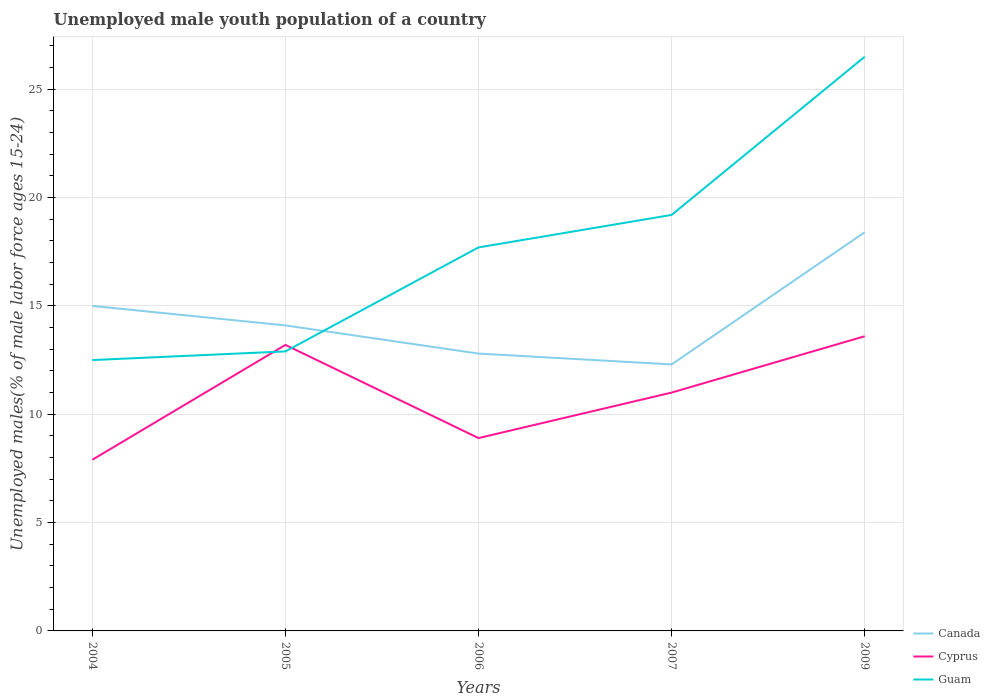How many different coloured lines are there?
Provide a short and direct response. 3. Is the number of lines equal to the number of legend labels?
Offer a very short reply. Yes. Across all years, what is the maximum percentage of unemployed male youth population in Canada?
Your response must be concise. 12.3. In which year was the percentage of unemployed male youth population in Guam maximum?
Your response must be concise. 2004. What is the total percentage of unemployed male youth population in Cyprus in the graph?
Offer a very short reply. 4.3. What is the difference between the highest and the second highest percentage of unemployed male youth population in Canada?
Keep it short and to the point. 6.1. What is the difference between the highest and the lowest percentage of unemployed male youth population in Canada?
Keep it short and to the point. 2. How many lines are there?
Offer a very short reply. 3. How many years are there in the graph?
Keep it short and to the point. 5. Are the values on the major ticks of Y-axis written in scientific E-notation?
Make the answer very short. No. Does the graph contain any zero values?
Provide a short and direct response. No. Does the graph contain grids?
Your answer should be very brief. Yes. How are the legend labels stacked?
Offer a terse response. Vertical. What is the title of the graph?
Provide a short and direct response. Unemployed male youth population of a country. What is the label or title of the X-axis?
Offer a terse response. Years. What is the label or title of the Y-axis?
Keep it short and to the point. Unemployed males(% of male labor force ages 15-24). What is the Unemployed males(% of male labor force ages 15-24) in Cyprus in 2004?
Offer a terse response. 7.9. What is the Unemployed males(% of male labor force ages 15-24) of Guam in 2004?
Offer a terse response. 12.5. What is the Unemployed males(% of male labor force ages 15-24) in Canada in 2005?
Offer a terse response. 14.1. What is the Unemployed males(% of male labor force ages 15-24) in Cyprus in 2005?
Your answer should be compact. 13.2. What is the Unemployed males(% of male labor force ages 15-24) in Guam in 2005?
Offer a very short reply. 12.9. What is the Unemployed males(% of male labor force ages 15-24) of Canada in 2006?
Give a very brief answer. 12.8. What is the Unemployed males(% of male labor force ages 15-24) in Cyprus in 2006?
Your answer should be very brief. 8.9. What is the Unemployed males(% of male labor force ages 15-24) in Guam in 2006?
Your response must be concise. 17.7. What is the Unemployed males(% of male labor force ages 15-24) of Canada in 2007?
Ensure brevity in your answer.  12.3. What is the Unemployed males(% of male labor force ages 15-24) in Guam in 2007?
Your response must be concise. 19.2. What is the Unemployed males(% of male labor force ages 15-24) in Canada in 2009?
Give a very brief answer. 18.4. What is the Unemployed males(% of male labor force ages 15-24) in Cyprus in 2009?
Provide a succinct answer. 13.6. Across all years, what is the maximum Unemployed males(% of male labor force ages 15-24) in Canada?
Give a very brief answer. 18.4. Across all years, what is the maximum Unemployed males(% of male labor force ages 15-24) of Cyprus?
Your answer should be compact. 13.6. Across all years, what is the maximum Unemployed males(% of male labor force ages 15-24) of Guam?
Offer a very short reply. 26.5. Across all years, what is the minimum Unemployed males(% of male labor force ages 15-24) of Canada?
Keep it short and to the point. 12.3. Across all years, what is the minimum Unemployed males(% of male labor force ages 15-24) in Cyprus?
Offer a very short reply. 7.9. Across all years, what is the minimum Unemployed males(% of male labor force ages 15-24) of Guam?
Provide a succinct answer. 12.5. What is the total Unemployed males(% of male labor force ages 15-24) in Canada in the graph?
Offer a very short reply. 72.6. What is the total Unemployed males(% of male labor force ages 15-24) of Cyprus in the graph?
Your response must be concise. 54.6. What is the total Unemployed males(% of male labor force ages 15-24) of Guam in the graph?
Keep it short and to the point. 88.8. What is the difference between the Unemployed males(% of male labor force ages 15-24) in Cyprus in 2004 and that in 2006?
Your answer should be very brief. -1. What is the difference between the Unemployed males(% of male labor force ages 15-24) in Guam in 2004 and that in 2006?
Your response must be concise. -5.2. What is the difference between the Unemployed males(% of male labor force ages 15-24) in Cyprus in 2004 and that in 2007?
Your response must be concise. -3.1. What is the difference between the Unemployed males(% of male labor force ages 15-24) in Canada in 2004 and that in 2009?
Give a very brief answer. -3.4. What is the difference between the Unemployed males(% of male labor force ages 15-24) in Guam in 2005 and that in 2006?
Give a very brief answer. -4.8. What is the difference between the Unemployed males(% of male labor force ages 15-24) in Cyprus in 2005 and that in 2007?
Give a very brief answer. 2.2. What is the difference between the Unemployed males(% of male labor force ages 15-24) of Guam in 2005 and that in 2007?
Provide a short and direct response. -6.3. What is the difference between the Unemployed males(% of male labor force ages 15-24) in Canada in 2005 and that in 2009?
Your answer should be very brief. -4.3. What is the difference between the Unemployed males(% of male labor force ages 15-24) of Guam in 2005 and that in 2009?
Your answer should be very brief. -13.6. What is the difference between the Unemployed males(% of male labor force ages 15-24) of Canada in 2006 and that in 2007?
Offer a very short reply. 0.5. What is the difference between the Unemployed males(% of male labor force ages 15-24) in Cyprus in 2006 and that in 2007?
Provide a succinct answer. -2.1. What is the difference between the Unemployed males(% of male labor force ages 15-24) of Canada in 2006 and that in 2009?
Make the answer very short. -5.6. What is the difference between the Unemployed males(% of male labor force ages 15-24) of Guam in 2006 and that in 2009?
Keep it short and to the point. -8.8. What is the difference between the Unemployed males(% of male labor force ages 15-24) in Cyprus in 2007 and that in 2009?
Your answer should be compact. -2.6. What is the difference between the Unemployed males(% of male labor force ages 15-24) in Canada in 2004 and the Unemployed males(% of male labor force ages 15-24) in Cyprus in 2005?
Provide a succinct answer. 1.8. What is the difference between the Unemployed males(% of male labor force ages 15-24) in Cyprus in 2004 and the Unemployed males(% of male labor force ages 15-24) in Guam in 2005?
Provide a short and direct response. -5. What is the difference between the Unemployed males(% of male labor force ages 15-24) of Canada in 2004 and the Unemployed males(% of male labor force ages 15-24) of Cyprus in 2006?
Your answer should be very brief. 6.1. What is the difference between the Unemployed males(% of male labor force ages 15-24) in Cyprus in 2004 and the Unemployed males(% of male labor force ages 15-24) in Guam in 2006?
Your answer should be very brief. -9.8. What is the difference between the Unemployed males(% of male labor force ages 15-24) of Canada in 2004 and the Unemployed males(% of male labor force ages 15-24) of Cyprus in 2007?
Your answer should be compact. 4. What is the difference between the Unemployed males(% of male labor force ages 15-24) in Canada in 2004 and the Unemployed males(% of male labor force ages 15-24) in Guam in 2007?
Your response must be concise. -4.2. What is the difference between the Unemployed males(% of male labor force ages 15-24) in Canada in 2004 and the Unemployed males(% of male labor force ages 15-24) in Cyprus in 2009?
Ensure brevity in your answer.  1.4. What is the difference between the Unemployed males(% of male labor force ages 15-24) of Canada in 2004 and the Unemployed males(% of male labor force ages 15-24) of Guam in 2009?
Ensure brevity in your answer.  -11.5. What is the difference between the Unemployed males(% of male labor force ages 15-24) of Cyprus in 2004 and the Unemployed males(% of male labor force ages 15-24) of Guam in 2009?
Your answer should be very brief. -18.6. What is the difference between the Unemployed males(% of male labor force ages 15-24) of Canada in 2005 and the Unemployed males(% of male labor force ages 15-24) of Guam in 2007?
Provide a succinct answer. -5.1. What is the difference between the Unemployed males(% of male labor force ages 15-24) of Cyprus in 2005 and the Unemployed males(% of male labor force ages 15-24) of Guam in 2007?
Make the answer very short. -6. What is the difference between the Unemployed males(% of male labor force ages 15-24) in Canada in 2005 and the Unemployed males(% of male labor force ages 15-24) in Cyprus in 2009?
Ensure brevity in your answer.  0.5. What is the difference between the Unemployed males(% of male labor force ages 15-24) in Canada in 2005 and the Unemployed males(% of male labor force ages 15-24) in Guam in 2009?
Keep it short and to the point. -12.4. What is the difference between the Unemployed males(% of male labor force ages 15-24) of Cyprus in 2005 and the Unemployed males(% of male labor force ages 15-24) of Guam in 2009?
Provide a short and direct response. -13.3. What is the difference between the Unemployed males(% of male labor force ages 15-24) of Canada in 2006 and the Unemployed males(% of male labor force ages 15-24) of Cyprus in 2007?
Your answer should be compact. 1.8. What is the difference between the Unemployed males(% of male labor force ages 15-24) in Canada in 2006 and the Unemployed males(% of male labor force ages 15-24) in Cyprus in 2009?
Make the answer very short. -0.8. What is the difference between the Unemployed males(% of male labor force ages 15-24) in Canada in 2006 and the Unemployed males(% of male labor force ages 15-24) in Guam in 2009?
Make the answer very short. -13.7. What is the difference between the Unemployed males(% of male labor force ages 15-24) in Cyprus in 2006 and the Unemployed males(% of male labor force ages 15-24) in Guam in 2009?
Your answer should be compact. -17.6. What is the difference between the Unemployed males(% of male labor force ages 15-24) of Cyprus in 2007 and the Unemployed males(% of male labor force ages 15-24) of Guam in 2009?
Give a very brief answer. -15.5. What is the average Unemployed males(% of male labor force ages 15-24) in Canada per year?
Provide a short and direct response. 14.52. What is the average Unemployed males(% of male labor force ages 15-24) in Cyprus per year?
Provide a succinct answer. 10.92. What is the average Unemployed males(% of male labor force ages 15-24) in Guam per year?
Offer a terse response. 17.76. In the year 2004, what is the difference between the Unemployed males(% of male labor force ages 15-24) of Canada and Unemployed males(% of male labor force ages 15-24) of Guam?
Make the answer very short. 2.5. In the year 2004, what is the difference between the Unemployed males(% of male labor force ages 15-24) of Cyprus and Unemployed males(% of male labor force ages 15-24) of Guam?
Keep it short and to the point. -4.6. In the year 2005, what is the difference between the Unemployed males(% of male labor force ages 15-24) in Canada and Unemployed males(% of male labor force ages 15-24) in Guam?
Your answer should be compact. 1.2. In the year 2005, what is the difference between the Unemployed males(% of male labor force ages 15-24) in Cyprus and Unemployed males(% of male labor force ages 15-24) in Guam?
Provide a succinct answer. 0.3. In the year 2006, what is the difference between the Unemployed males(% of male labor force ages 15-24) of Canada and Unemployed males(% of male labor force ages 15-24) of Cyprus?
Provide a short and direct response. 3.9. In the year 2006, what is the difference between the Unemployed males(% of male labor force ages 15-24) in Canada and Unemployed males(% of male labor force ages 15-24) in Guam?
Make the answer very short. -4.9. In the year 2006, what is the difference between the Unemployed males(% of male labor force ages 15-24) of Cyprus and Unemployed males(% of male labor force ages 15-24) of Guam?
Your response must be concise. -8.8. In the year 2007, what is the difference between the Unemployed males(% of male labor force ages 15-24) in Canada and Unemployed males(% of male labor force ages 15-24) in Cyprus?
Ensure brevity in your answer.  1.3. In the year 2007, what is the difference between the Unemployed males(% of male labor force ages 15-24) of Cyprus and Unemployed males(% of male labor force ages 15-24) of Guam?
Make the answer very short. -8.2. In the year 2009, what is the difference between the Unemployed males(% of male labor force ages 15-24) of Canada and Unemployed males(% of male labor force ages 15-24) of Guam?
Your answer should be very brief. -8.1. What is the ratio of the Unemployed males(% of male labor force ages 15-24) in Canada in 2004 to that in 2005?
Provide a short and direct response. 1.06. What is the ratio of the Unemployed males(% of male labor force ages 15-24) of Cyprus in 2004 to that in 2005?
Your answer should be compact. 0.6. What is the ratio of the Unemployed males(% of male labor force ages 15-24) in Guam in 2004 to that in 2005?
Your response must be concise. 0.97. What is the ratio of the Unemployed males(% of male labor force ages 15-24) in Canada in 2004 to that in 2006?
Your answer should be very brief. 1.17. What is the ratio of the Unemployed males(% of male labor force ages 15-24) of Cyprus in 2004 to that in 2006?
Provide a short and direct response. 0.89. What is the ratio of the Unemployed males(% of male labor force ages 15-24) of Guam in 2004 to that in 2006?
Provide a succinct answer. 0.71. What is the ratio of the Unemployed males(% of male labor force ages 15-24) in Canada in 2004 to that in 2007?
Your answer should be very brief. 1.22. What is the ratio of the Unemployed males(% of male labor force ages 15-24) of Cyprus in 2004 to that in 2007?
Your answer should be compact. 0.72. What is the ratio of the Unemployed males(% of male labor force ages 15-24) of Guam in 2004 to that in 2007?
Keep it short and to the point. 0.65. What is the ratio of the Unemployed males(% of male labor force ages 15-24) in Canada in 2004 to that in 2009?
Give a very brief answer. 0.82. What is the ratio of the Unemployed males(% of male labor force ages 15-24) of Cyprus in 2004 to that in 2009?
Provide a short and direct response. 0.58. What is the ratio of the Unemployed males(% of male labor force ages 15-24) of Guam in 2004 to that in 2009?
Provide a succinct answer. 0.47. What is the ratio of the Unemployed males(% of male labor force ages 15-24) of Canada in 2005 to that in 2006?
Your response must be concise. 1.1. What is the ratio of the Unemployed males(% of male labor force ages 15-24) of Cyprus in 2005 to that in 2006?
Give a very brief answer. 1.48. What is the ratio of the Unemployed males(% of male labor force ages 15-24) in Guam in 2005 to that in 2006?
Give a very brief answer. 0.73. What is the ratio of the Unemployed males(% of male labor force ages 15-24) in Canada in 2005 to that in 2007?
Your answer should be very brief. 1.15. What is the ratio of the Unemployed males(% of male labor force ages 15-24) in Guam in 2005 to that in 2007?
Keep it short and to the point. 0.67. What is the ratio of the Unemployed males(% of male labor force ages 15-24) in Canada in 2005 to that in 2009?
Keep it short and to the point. 0.77. What is the ratio of the Unemployed males(% of male labor force ages 15-24) in Cyprus in 2005 to that in 2009?
Your answer should be very brief. 0.97. What is the ratio of the Unemployed males(% of male labor force ages 15-24) of Guam in 2005 to that in 2009?
Offer a terse response. 0.49. What is the ratio of the Unemployed males(% of male labor force ages 15-24) in Canada in 2006 to that in 2007?
Give a very brief answer. 1.04. What is the ratio of the Unemployed males(% of male labor force ages 15-24) in Cyprus in 2006 to that in 2007?
Your answer should be very brief. 0.81. What is the ratio of the Unemployed males(% of male labor force ages 15-24) in Guam in 2006 to that in 2007?
Offer a terse response. 0.92. What is the ratio of the Unemployed males(% of male labor force ages 15-24) in Canada in 2006 to that in 2009?
Ensure brevity in your answer.  0.7. What is the ratio of the Unemployed males(% of male labor force ages 15-24) in Cyprus in 2006 to that in 2009?
Your response must be concise. 0.65. What is the ratio of the Unemployed males(% of male labor force ages 15-24) in Guam in 2006 to that in 2009?
Your answer should be very brief. 0.67. What is the ratio of the Unemployed males(% of male labor force ages 15-24) of Canada in 2007 to that in 2009?
Offer a very short reply. 0.67. What is the ratio of the Unemployed males(% of male labor force ages 15-24) in Cyprus in 2007 to that in 2009?
Your answer should be very brief. 0.81. What is the ratio of the Unemployed males(% of male labor force ages 15-24) in Guam in 2007 to that in 2009?
Your answer should be very brief. 0.72. What is the difference between the highest and the second highest Unemployed males(% of male labor force ages 15-24) in Canada?
Keep it short and to the point. 3.4. What is the difference between the highest and the second highest Unemployed males(% of male labor force ages 15-24) of Guam?
Provide a succinct answer. 7.3. What is the difference between the highest and the lowest Unemployed males(% of male labor force ages 15-24) of Canada?
Provide a short and direct response. 6.1. What is the difference between the highest and the lowest Unemployed males(% of male labor force ages 15-24) of Cyprus?
Your answer should be compact. 5.7. What is the difference between the highest and the lowest Unemployed males(% of male labor force ages 15-24) in Guam?
Your answer should be very brief. 14. 